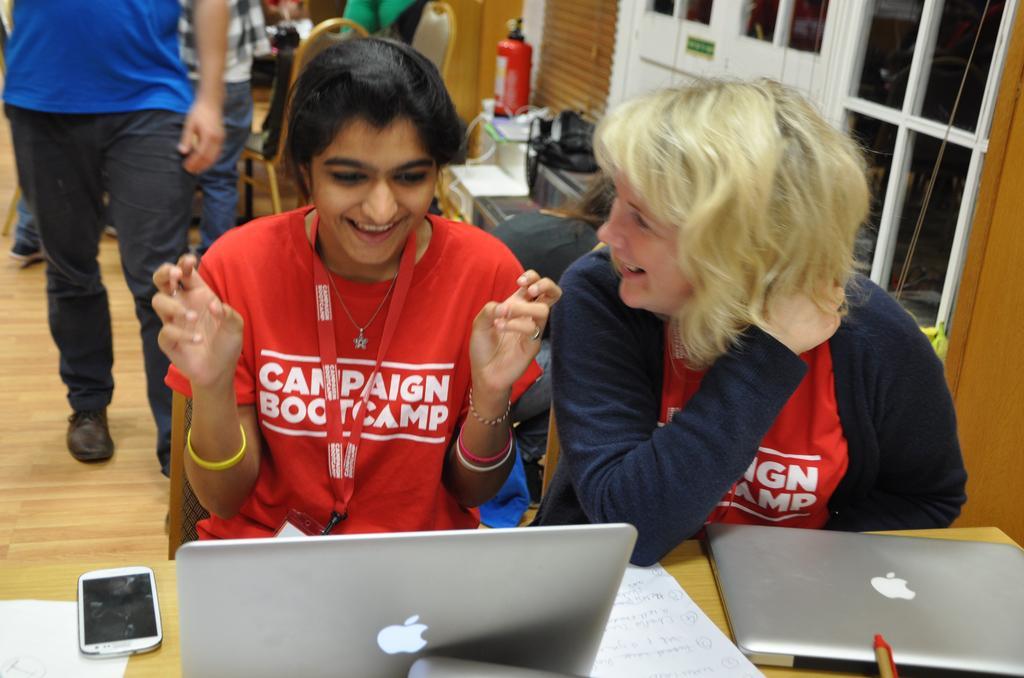Could you give a brief overview of what you see in this image? There is a lady with red color t-shirt is sitting on a chair. She is smiling. Beside her there is another lady with blue color jacket is sitting and she is smiling. In front of them there is a table. On the table there are laptops, paper , mobile phone. In the background there is a person walking. There are some chairs, fire extinguisher, window, black color bag. 